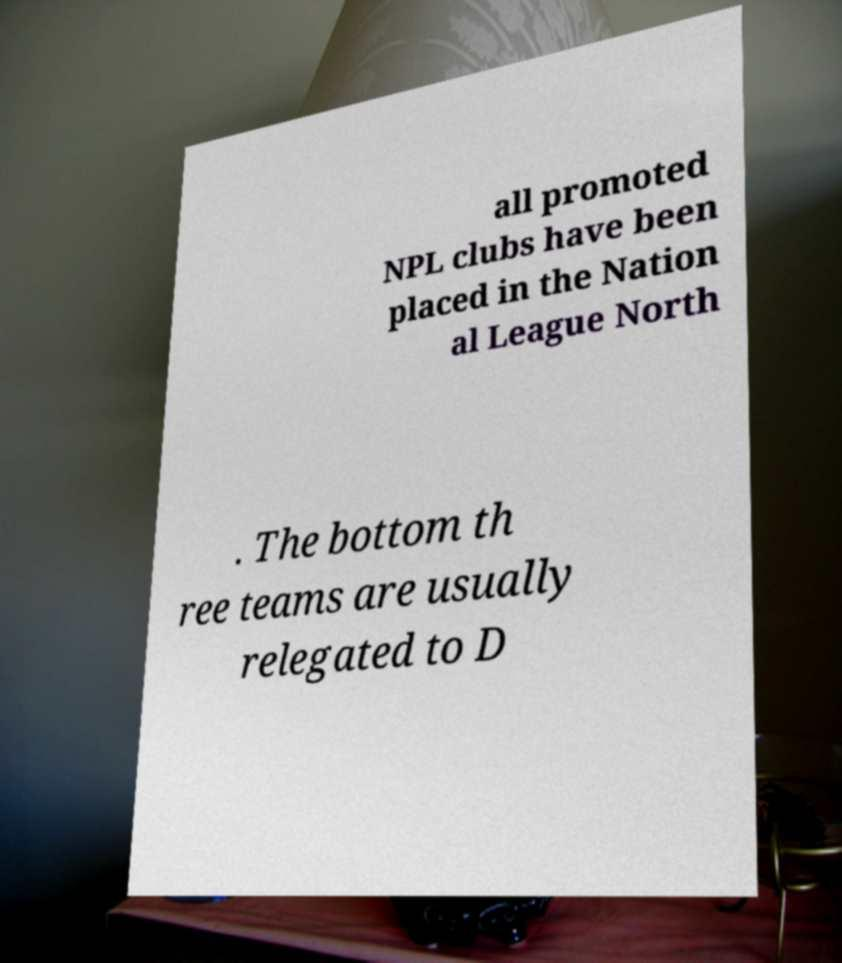Please read and relay the text visible in this image. What does it say? all promoted NPL clubs have been placed in the Nation al League North . The bottom th ree teams are usually relegated to D 